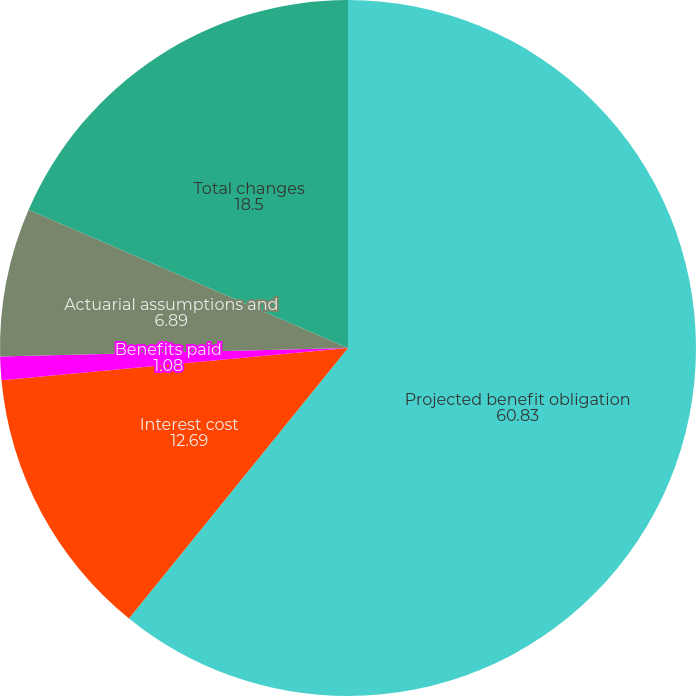<chart> <loc_0><loc_0><loc_500><loc_500><pie_chart><fcel>Projected benefit obligation<fcel>Interest cost<fcel>Benefits paid<fcel>Actuarial assumptions and<fcel>Total changes<nl><fcel>60.83%<fcel>12.69%<fcel>1.08%<fcel>6.89%<fcel>18.5%<nl></chart> 